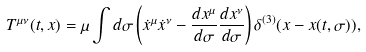<formula> <loc_0><loc_0><loc_500><loc_500>T ^ { \mu \nu } ( t , x ) = \mu \int d \sigma \left ( \dot { x } ^ { \mu } \dot { x } ^ { \nu } - \frac { d x ^ { \mu } } { d \sigma } \frac { d x ^ { \nu } } { d \sigma } \right ) \delta ^ { ( 3 ) } ( x - x ( t , \sigma ) ) ,</formula> 